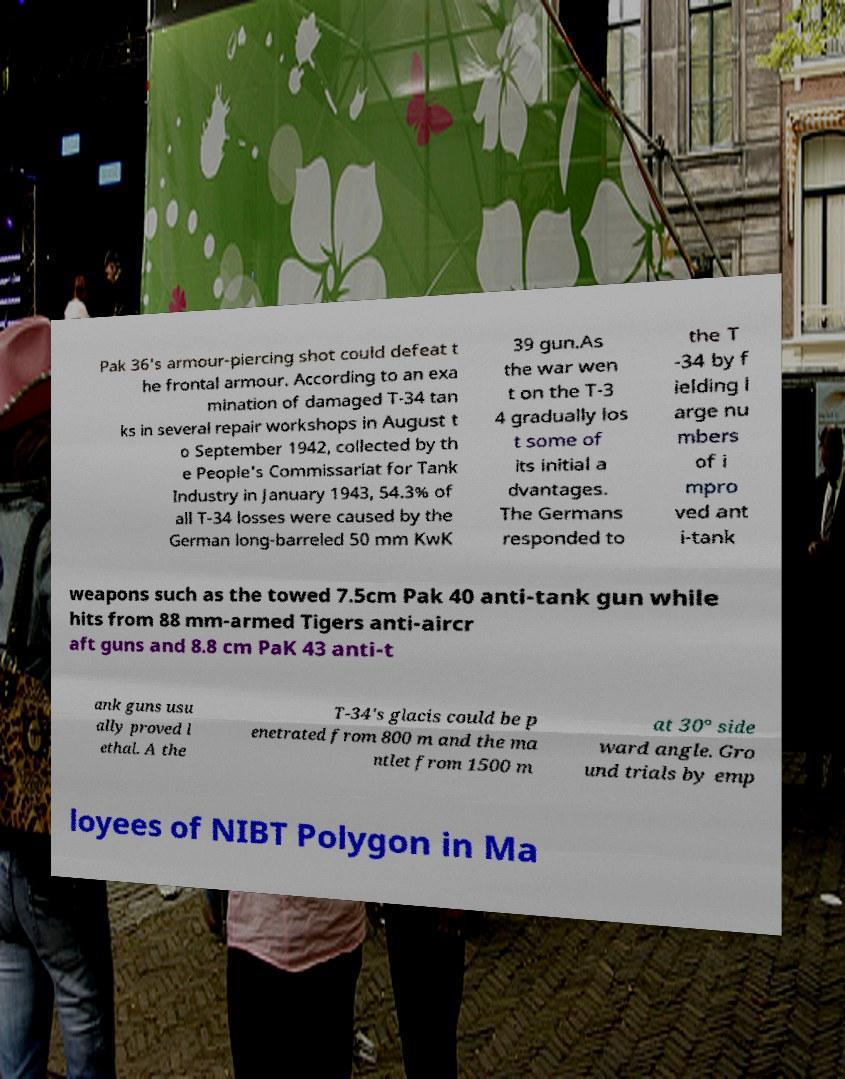I need the written content from this picture converted into text. Can you do that? Pak 36's armour-piercing shot could defeat t he frontal armour. According to an exa mination of damaged T-34 tan ks in several repair workshops in August t o September 1942, collected by th e People's Commissariat for Tank Industry in January 1943, 54.3% of all T-34 losses were caused by the German long-barreled 50 mm KwK 39 gun.As the war wen t on the T-3 4 gradually los t some of its initial a dvantages. The Germans responded to the T -34 by f ielding l arge nu mbers of i mpro ved ant i-tank weapons such as the towed 7.5cm Pak 40 anti-tank gun while hits from 88 mm-armed Tigers anti-aircr aft guns and 8.8 cm PaK 43 anti-t ank guns usu ally proved l ethal. A the T-34's glacis could be p enetrated from 800 m and the ma ntlet from 1500 m at 30° side ward angle. Gro und trials by emp loyees of NIBT Polygon in Ma 